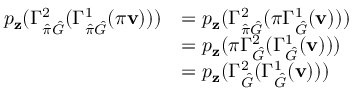Convert formula to latex. <formula><loc_0><loc_0><loc_500><loc_500>\begin{array} { r l } { p _ { z } ( \Gamma _ { \hat { \pi } \hat { G } } ^ { 2 } ( \Gamma _ { \hat { \pi } \hat { G } } ^ { 1 } ( \pi v ) ) ) } & { = p _ { z } ( \Gamma _ { \hat { \pi } \hat { G } } ^ { 2 } ( \pi \Gamma _ { \hat { G } } ^ { 1 } ( v ) ) ) } \\ & { = p _ { z } ( \pi \Gamma _ { \hat { G } } ^ { 2 } ( \Gamma _ { \hat { G } } ^ { 1 } ( v ) ) ) } \\ & { = p _ { z } ( \Gamma _ { \hat { G } } ^ { 2 } ( \Gamma _ { \hat { G } } ^ { 1 } ( v ) ) ) } \end{array}</formula> 